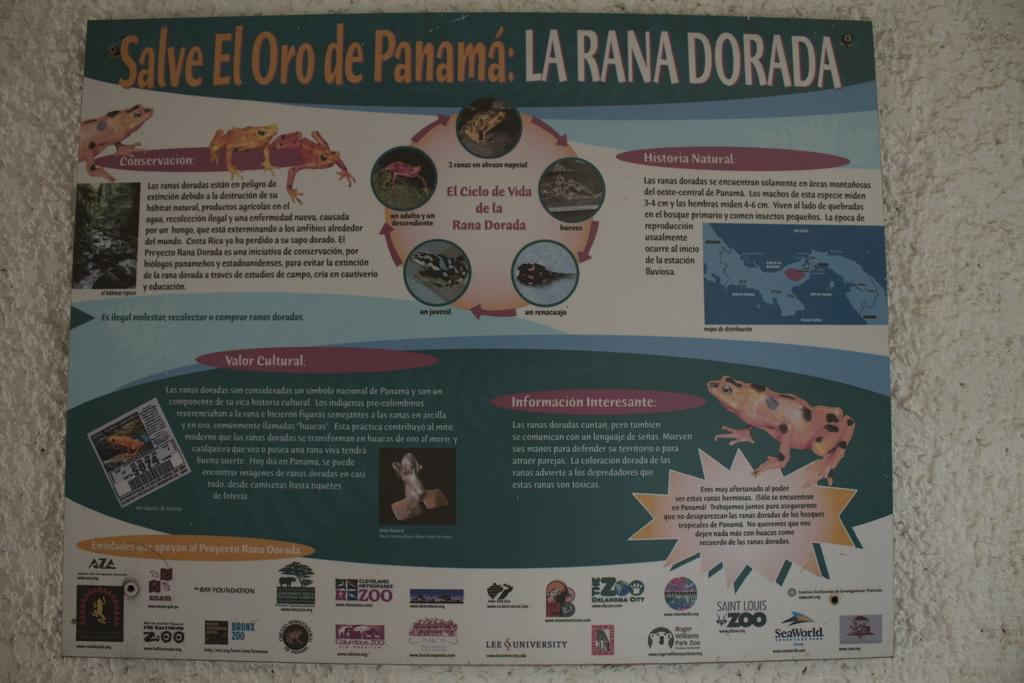<image>
Give a short and clear explanation of the subsequent image. An infographic titled Salve El Oro De Panama. 